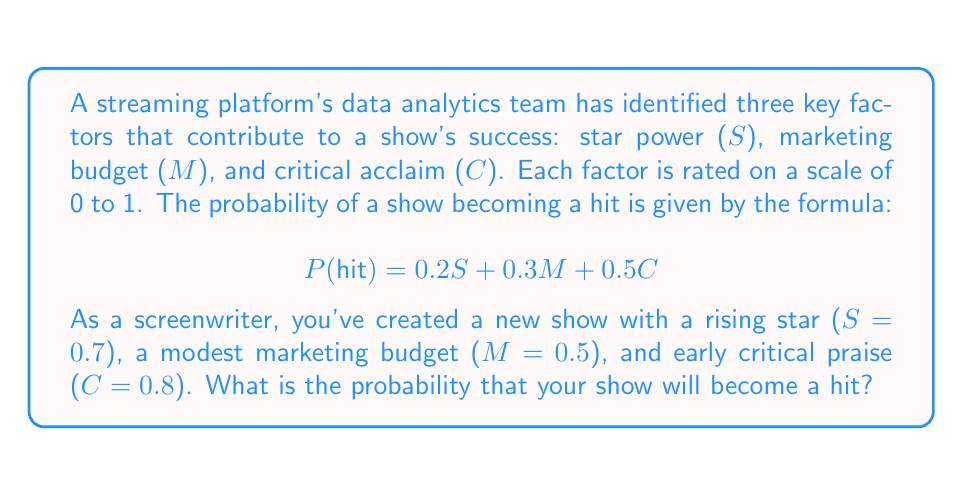Provide a solution to this math problem. To solve this problem, we'll follow these steps:

1) We have the formula for the probability of a show becoming a hit:
   $$ P(hit) = 0.2S + 0.3M + 0.5C $$

2) We're given the values for each factor:
   $S = 0.7$ (star power)
   $M = 0.5$ (marketing budget)
   $C = 0.8$ (critical acclaim)

3) Let's substitute these values into the formula:
   $$ P(hit) = 0.2(0.7) + 0.3(0.5) + 0.5(0.8) $$

4) Now, let's calculate each term:
   $0.2(0.7) = 0.14$
   $0.3(0.5) = 0.15$
   $0.5(0.8) = 0.40$

5) Finally, we sum these values:
   $$ P(hit) = 0.14 + 0.15 + 0.40 = 0.69 $$

Therefore, the probability of your show becoming a hit is 0.69 or 69%.
Answer: 0.69 